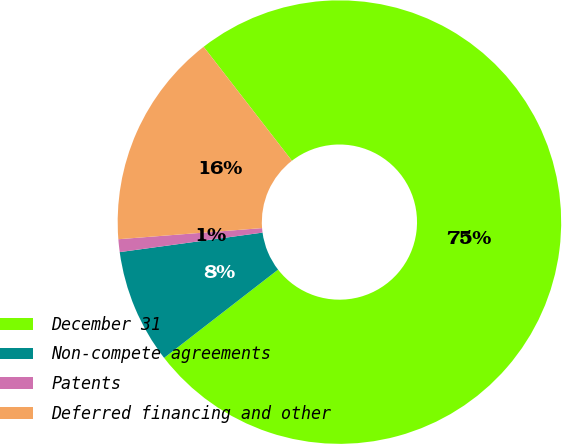Convert chart to OTSL. <chart><loc_0><loc_0><loc_500><loc_500><pie_chart><fcel>December 31<fcel>Non-compete agreements<fcel>Patents<fcel>Deferred financing and other<nl><fcel>75.0%<fcel>8.33%<fcel>0.93%<fcel>15.74%<nl></chart> 